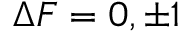<formula> <loc_0><loc_0><loc_500><loc_500>\Delta F = 0 , \pm 1</formula> 